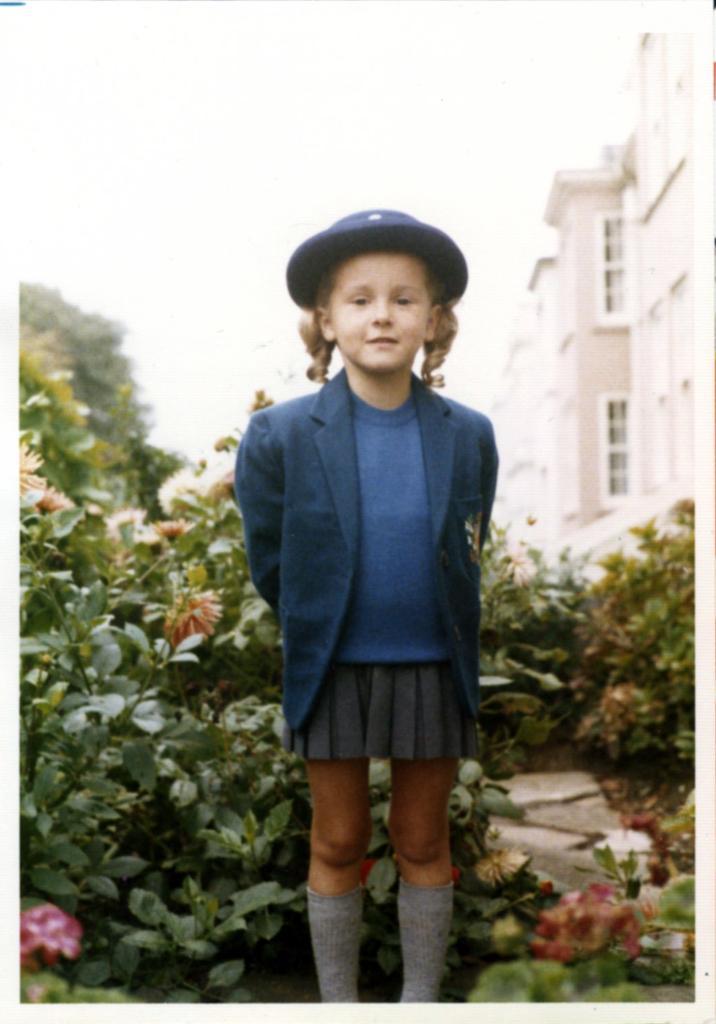Describe this image in one or two sentences. In this picture I can see a girl is standing. The girl is wearing a hat, black color coat and a skirt. In the background I can see plants, the sky and buildings. 